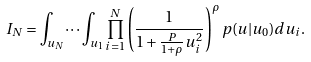Convert formula to latex. <formula><loc_0><loc_0><loc_500><loc_500>I _ { N } = \int _ { u _ { N } } \dots \int _ { u _ { 1 } } \prod _ { i = 1 } ^ { N } \left ( \frac { 1 } { 1 + \frac { P } { 1 + \rho } u _ { i } ^ { 2 } } \right ) ^ { \rho } p ( u | u _ { 0 } ) d u _ { i } .</formula> 